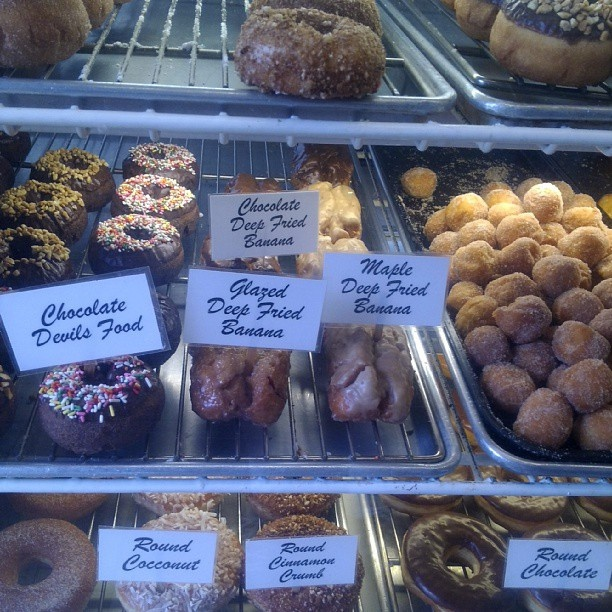Describe the objects in this image and their specific colors. I can see donut in gray and black tones, donut in gray, navy, purple, and black tones, donut in gray and black tones, donut in gray, navy, and black tones, and donut in gray and darkgray tones in this image. 